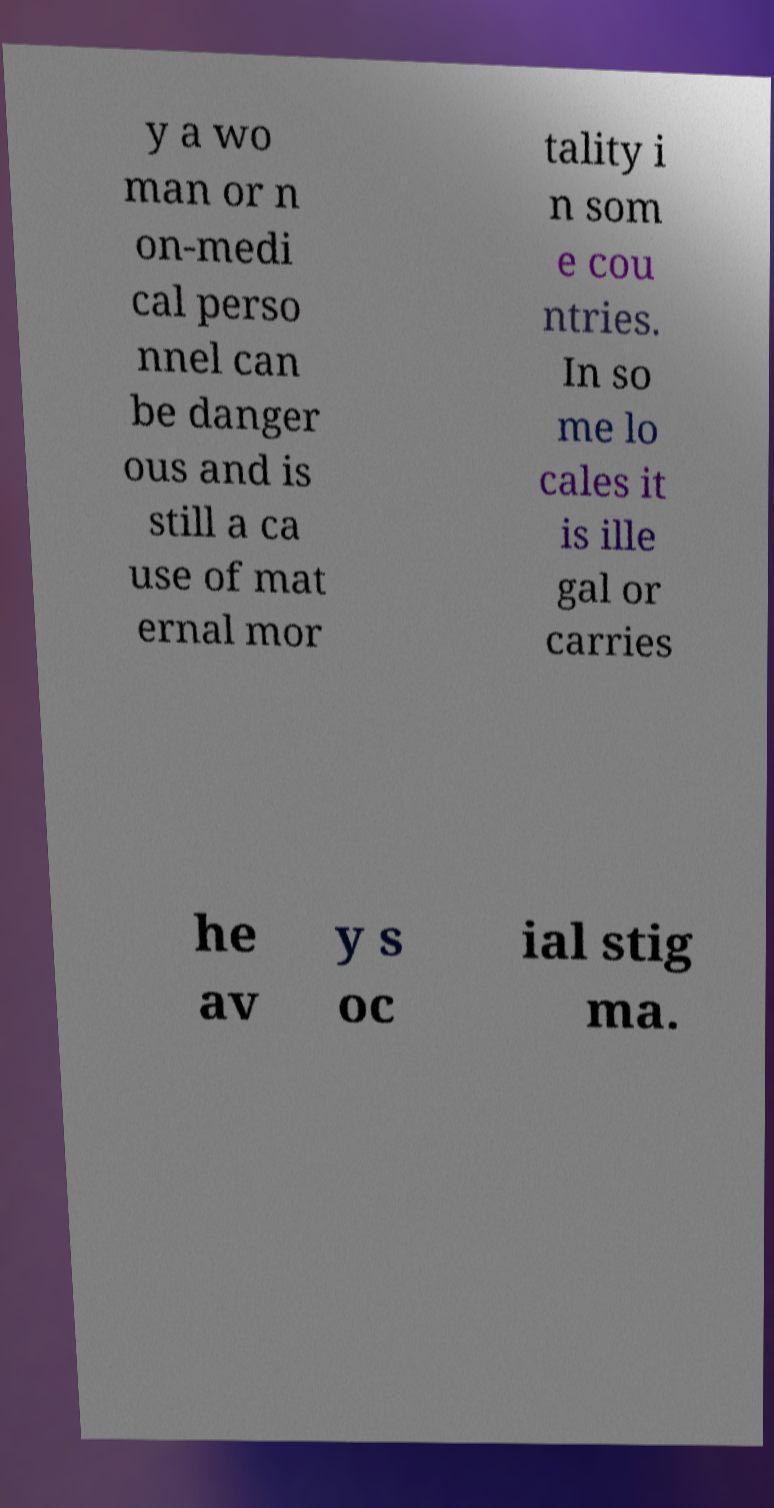Please identify and transcribe the text found in this image. y a wo man or n on-medi cal perso nnel can be danger ous and is still a ca use of mat ernal mor tality i n som e cou ntries. In so me lo cales it is ille gal or carries he av y s oc ial stig ma. 